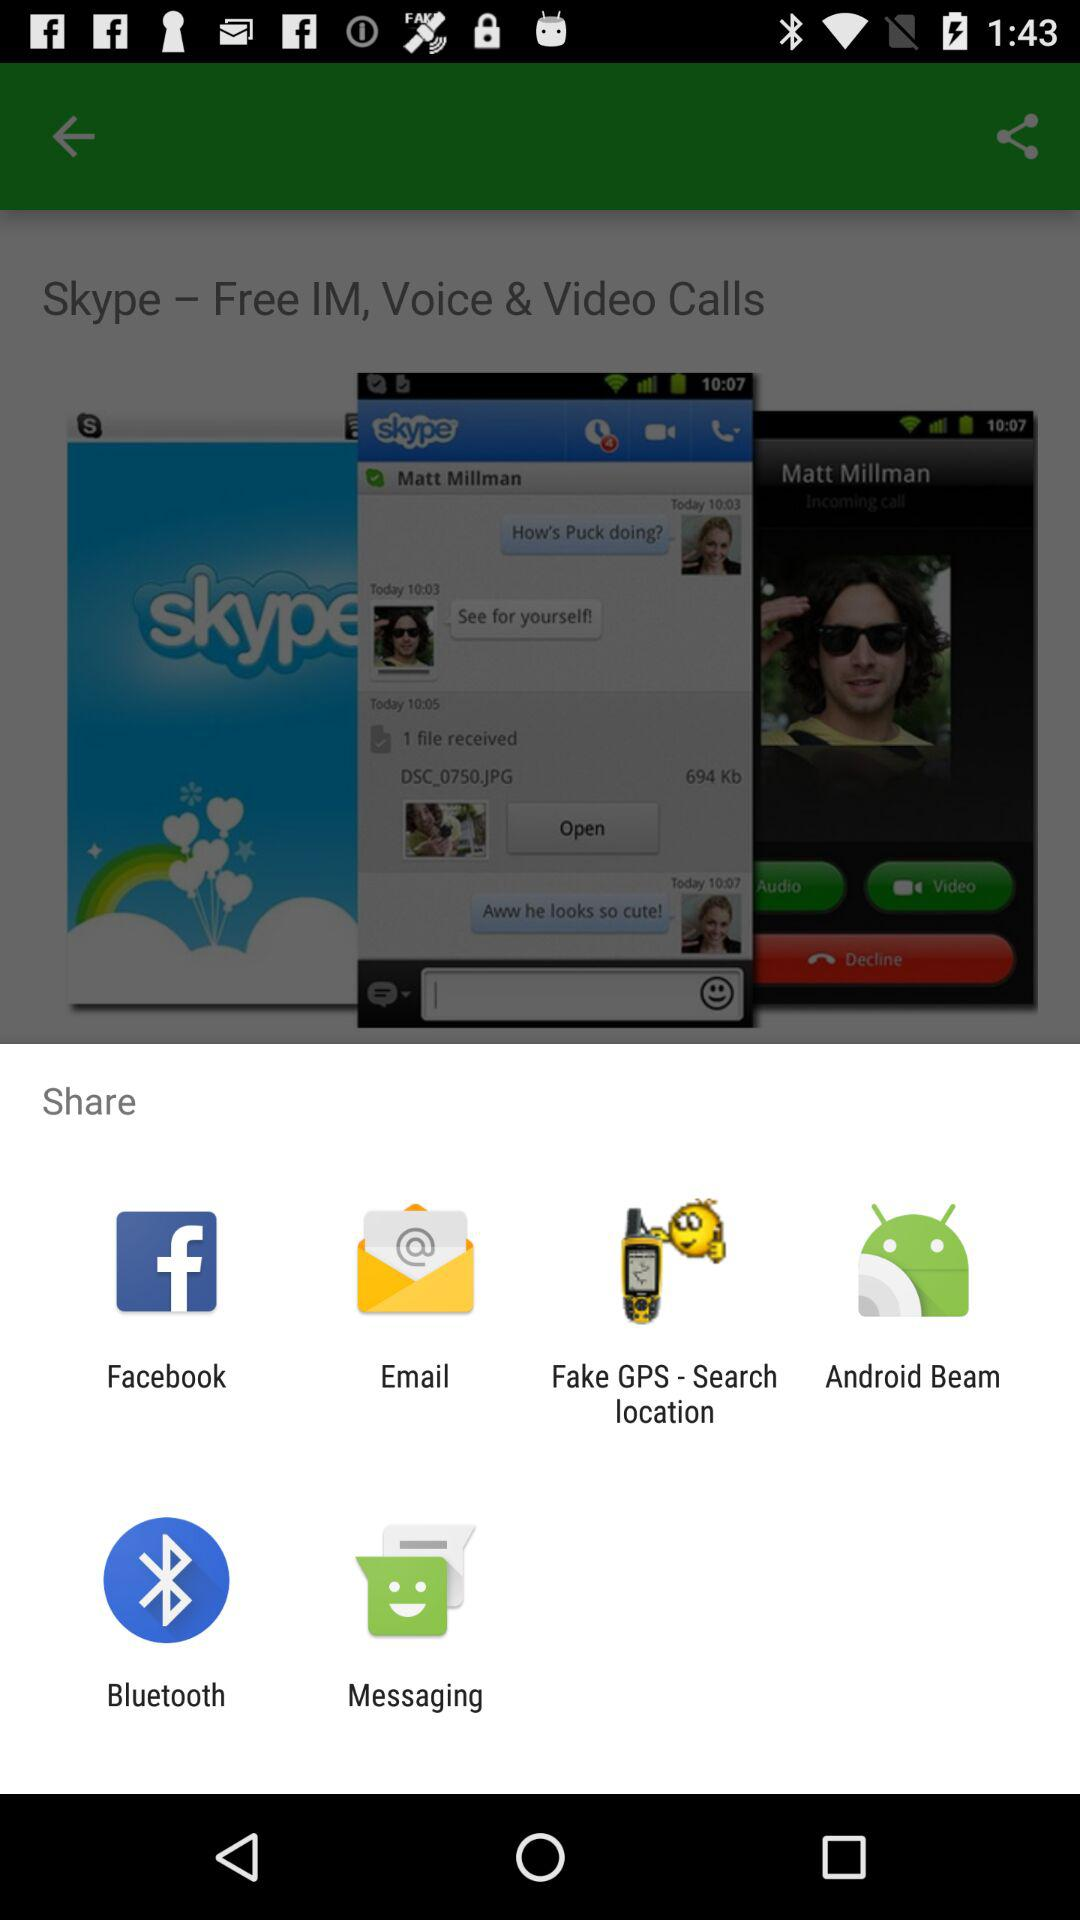Which application can we use for sharing? The applications that you can use for sharing are "Facebook", "Email", "Fake GPS - Search location", "Android Beam", "Bluetooth" and "Messaging". 